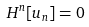<formula> <loc_0><loc_0><loc_500><loc_500>H ^ { n } [ u _ { n } ] = 0</formula> 